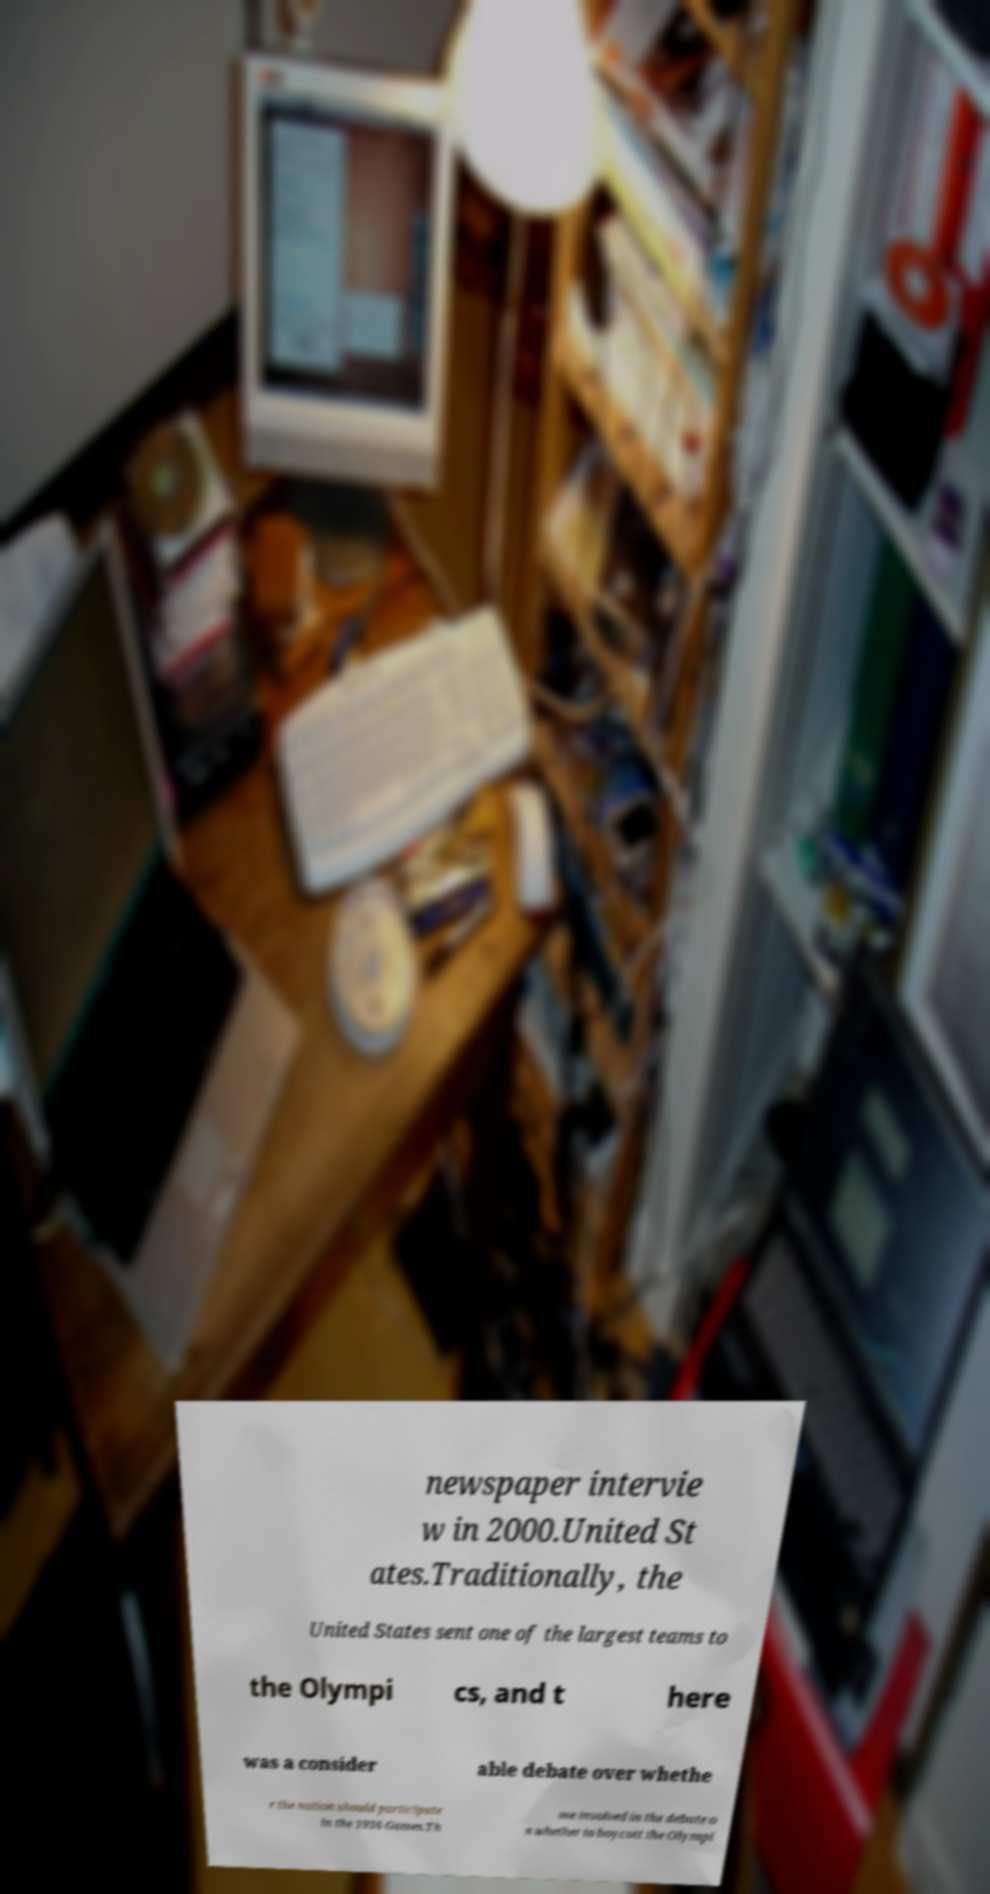I need the written content from this picture converted into text. Can you do that? newspaper intervie w in 2000.United St ates.Traditionally, the United States sent one of the largest teams to the Olympi cs, and t here was a consider able debate over whethe r the nation should participate in the 1936 Games.Th ose involved in the debate o n whether to boycott the Olympi 